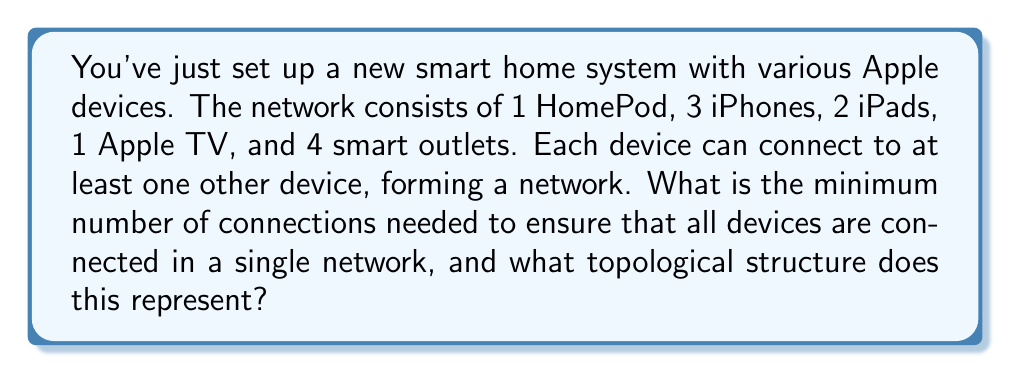Can you answer this question? Let's approach this step-by-step:

1. First, we need to count the total number of devices:
   1 HomePod + 3 iPhones + 2 iPads + 1 Apple TV + 4 smart outlets = 11 devices

2. In topology, this network can be represented as a graph, where each device is a vertex.

3. The minimum number of connections needed to ensure all devices are connected in a single network is equal to the number of edges in a spanning tree of this graph.

4. A spanning tree is a tree that includes all vertices of the graph with the minimum possible number of edges.

5. For a graph with $n$ vertices, the number of edges in a spanning tree is always $n - 1$.

6. In this case, we have 11 vertices, so the minimum number of connections needed is:

   $$11 - 1 = 10$$

7. This topological structure represents a tree. Specifically, it's a spanning tree of the complete graph on 11 vertices.

8. In graph theory notation, this can be written as a spanning tree of $K_{11}$, where $K_{11}$ represents the complete graph on 11 vertices.

9. This tree structure ensures connectivity with the minimum number of edges, which in a smart home context might represent wireless connections or data paths between devices.
Answer: The minimum number of connections needed is 10, and this represents a spanning tree of the complete graph $K_{11}$. 